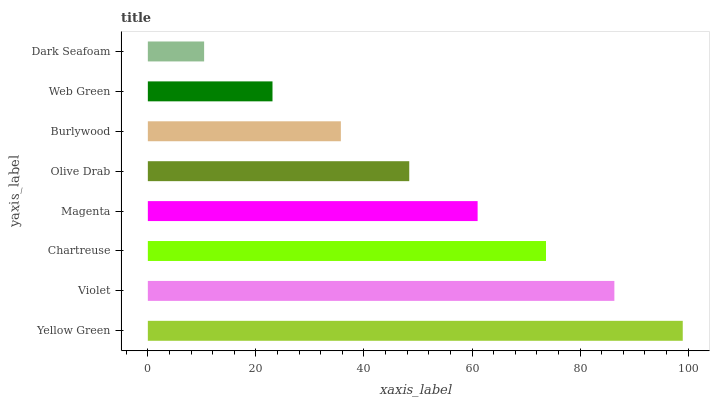Is Dark Seafoam the minimum?
Answer yes or no. Yes. Is Yellow Green the maximum?
Answer yes or no. Yes. Is Violet the minimum?
Answer yes or no. No. Is Violet the maximum?
Answer yes or no. No. Is Yellow Green greater than Violet?
Answer yes or no. Yes. Is Violet less than Yellow Green?
Answer yes or no. Yes. Is Violet greater than Yellow Green?
Answer yes or no. No. Is Yellow Green less than Violet?
Answer yes or no. No. Is Magenta the high median?
Answer yes or no. Yes. Is Olive Drab the low median?
Answer yes or no. Yes. Is Web Green the high median?
Answer yes or no. No. Is Dark Seafoam the low median?
Answer yes or no. No. 